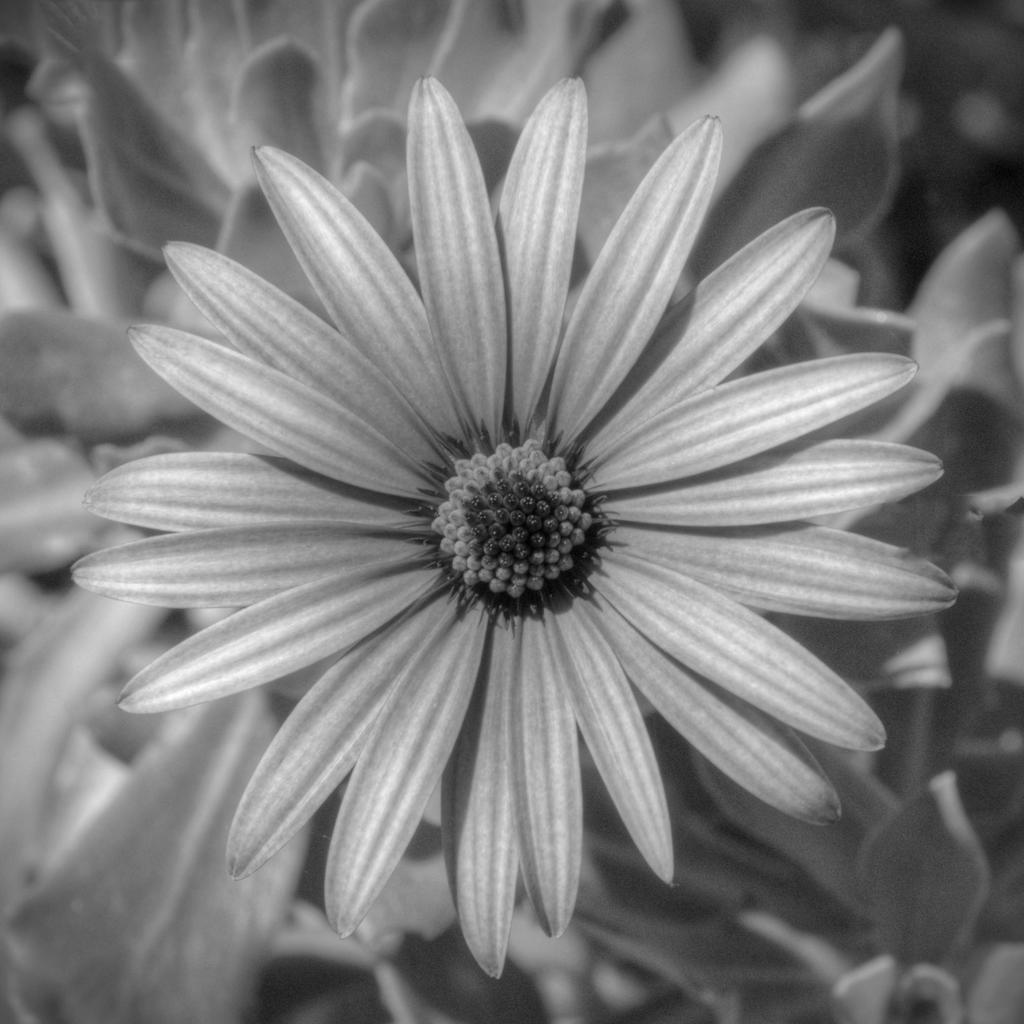Describe this image in one or two sentences. This is an edited picture. In the center of the picture there is a flower. In the background there are plants. 